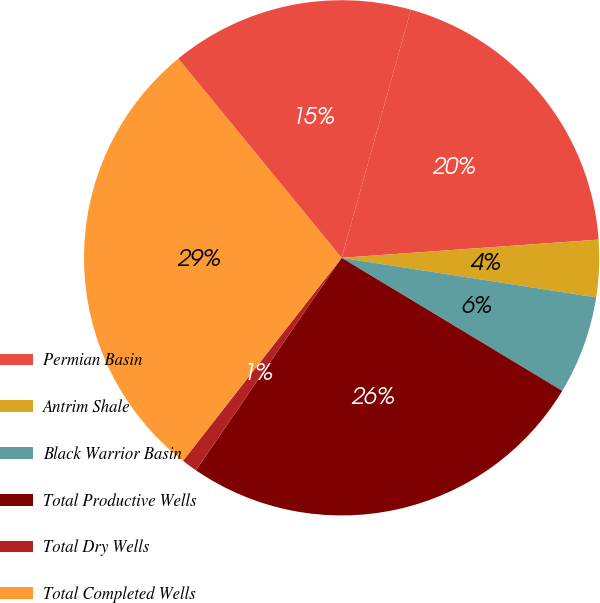Convert chart to OTSL. <chart><loc_0><loc_0><loc_500><loc_500><pie_chart><fcel>Permian Basin<fcel>Antrim Shale<fcel>Black Warrior Basin<fcel>Total Productive Wells<fcel>Total Dry Wells<fcel>Total Completed Wells<fcel>Total Wells in Progress<nl><fcel>19.54%<fcel>3.58%<fcel>6.18%<fcel>25.93%<fcel>0.99%<fcel>28.52%<fcel>15.26%<nl></chart> 